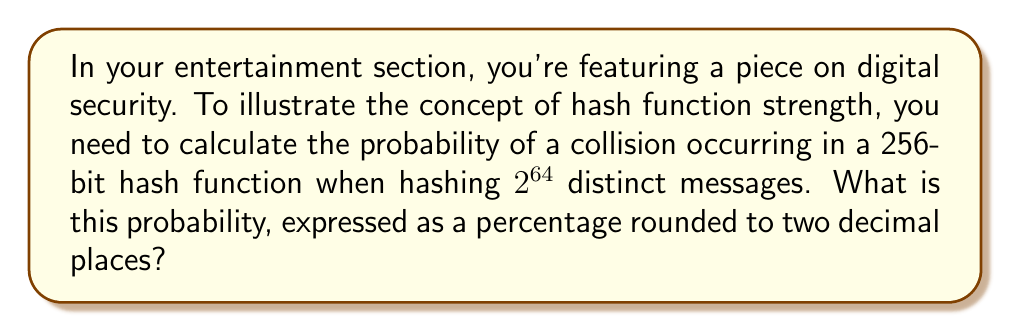Help me with this question. To solve this problem, we'll use the birthday attack probability formula and follow these steps:

1) The birthday attack probability formula for a hash function with $n$ bits and $m$ distinct messages is:

   $$P(\text{collision}) \approx 1 - e^{-\frac{m^2}{2^{n+1}}}$$

2) In this case, $n = 256$ (256-bit hash function) and $m = 2^{64}$ (number of distinct messages).

3) Let's substitute these values into the formula:

   $$P(\text{collision}) \approx 1 - e^{-\frac{(2^{64})^2}{2^{256+1}}}$$

4) Simplify the exponent:

   $$P(\text{collision}) \approx 1 - e^{-\frac{2^{128}}{2^{257}}} = 1 - e^{-\frac{1}{2^{129}}}$$

5) Calculate the value inside the exponential:

   $$\frac{1}{2^{129}} \approx 1.4693 \times 10^{-39}$$

6) Now we can calculate the probability:

   $$P(\text{collision}) \approx 1 - e^{-1.4693 \times 10^{-39}} \approx 1.4693 \times 10^{-39}$$

7) Convert to a percentage:

   $$1.4693 \times 10^{-39} \times 100\% \approx 1.4693 \times 10^{-37}\%$$

8) Rounding to two decimal places:

   $$1.4693 \times 10^{-37}\% \approx 0.00\%$$
Answer: 0.00% 